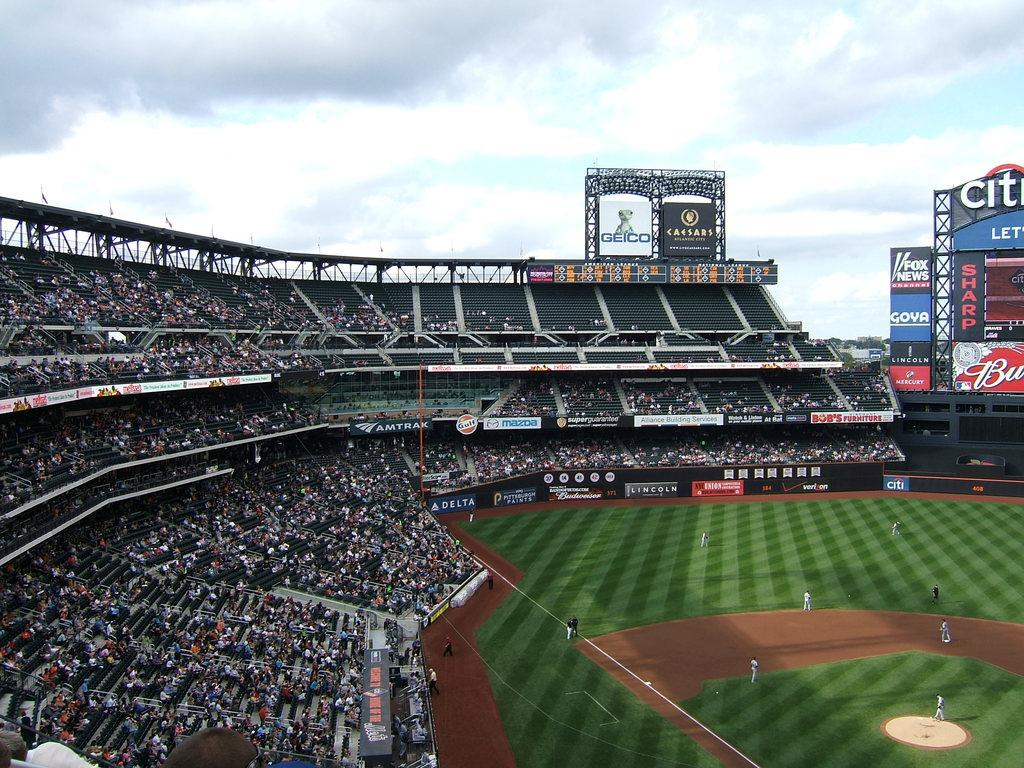<image>
Provide a brief description of the given image. Bob's Furniture is one of the sponsors of this baseball stadium. 